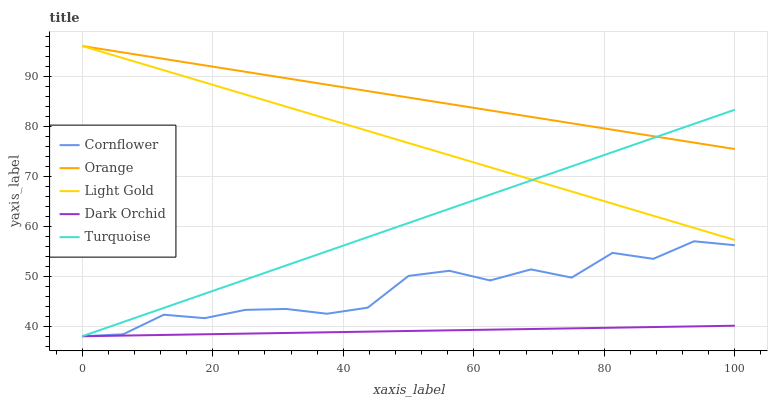Does Dark Orchid have the minimum area under the curve?
Answer yes or no. Yes. Does Orange have the maximum area under the curve?
Answer yes or no. Yes. Does Cornflower have the minimum area under the curve?
Answer yes or no. No. Does Cornflower have the maximum area under the curve?
Answer yes or no. No. Is Orange the smoothest?
Answer yes or no. Yes. Is Cornflower the roughest?
Answer yes or no. Yes. Is Turquoise the smoothest?
Answer yes or no. No. Is Turquoise the roughest?
Answer yes or no. No. Does Cornflower have the lowest value?
Answer yes or no. Yes. Does Light Gold have the lowest value?
Answer yes or no. No. Does Light Gold have the highest value?
Answer yes or no. Yes. Does Cornflower have the highest value?
Answer yes or no. No. Is Cornflower less than Orange?
Answer yes or no. Yes. Is Light Gold greater than Cornflower?
Answer yes or no. Yes. Does Cornflower intersect Dark Orchid?
Answer yes or no. Yes. Is Cornflower less than Dark Orchid?
Answer yes or no. No. Is Cornflower greater than Dark Orchid?
Answer yes or no. No. Does Cornflower intersect Orange?
Answer yes or no. No. 